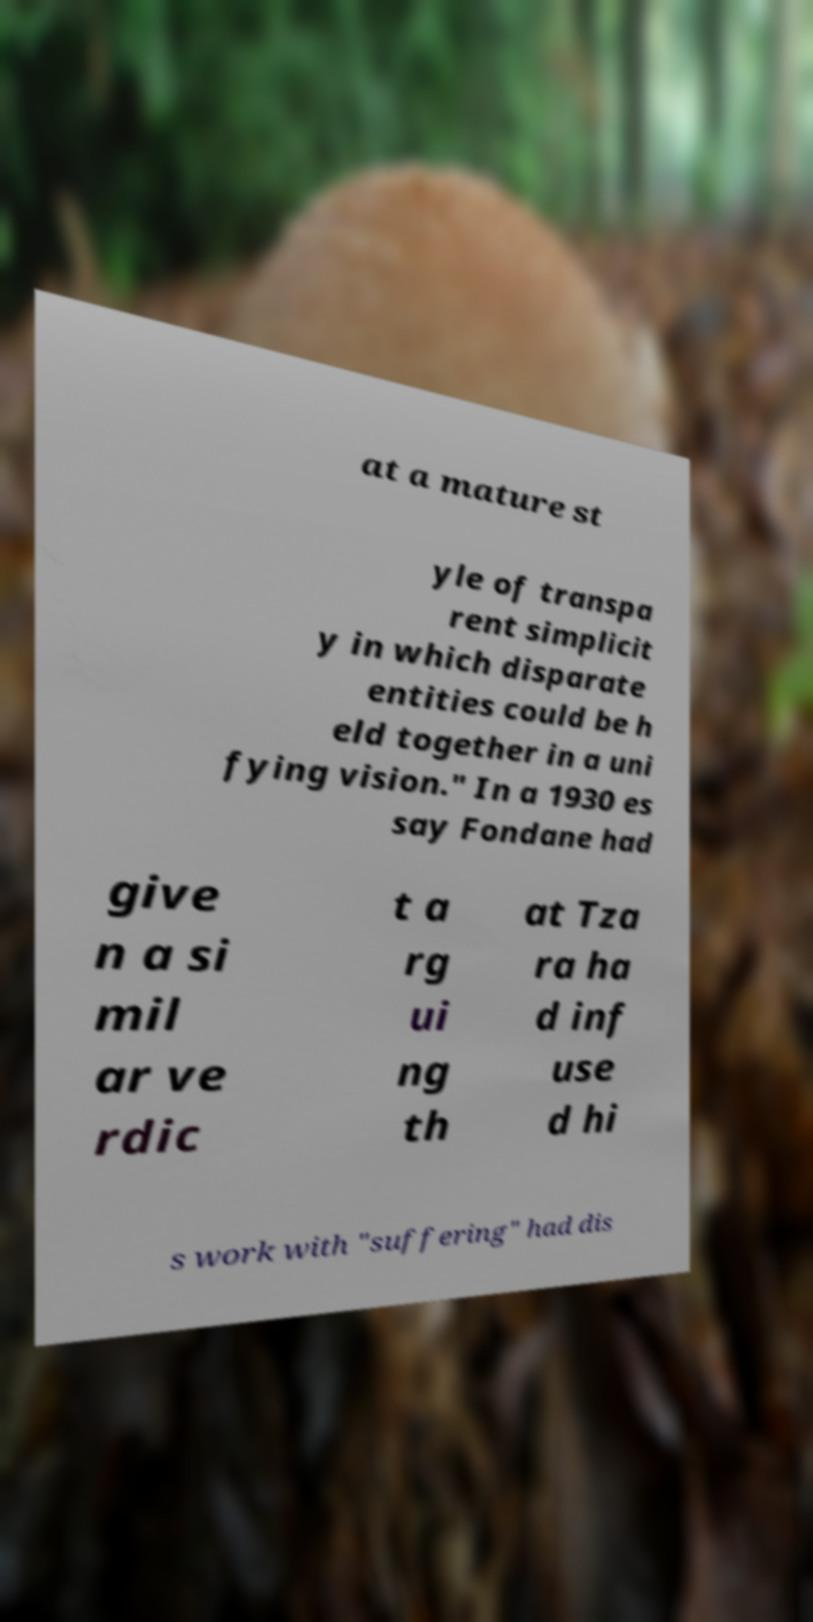For documentation purposes, I need the text within this image transcribed. Could you provide that? at a mature st yle of transpa rent simplicit y in which disparate entities could be h eld together in a uni fying vision." In a 1930 es say Fondane had give n a si mil ar ve rdic t a rg ui ng th at Tza ra ha d inf use d hi s work with "suffering" had dis 